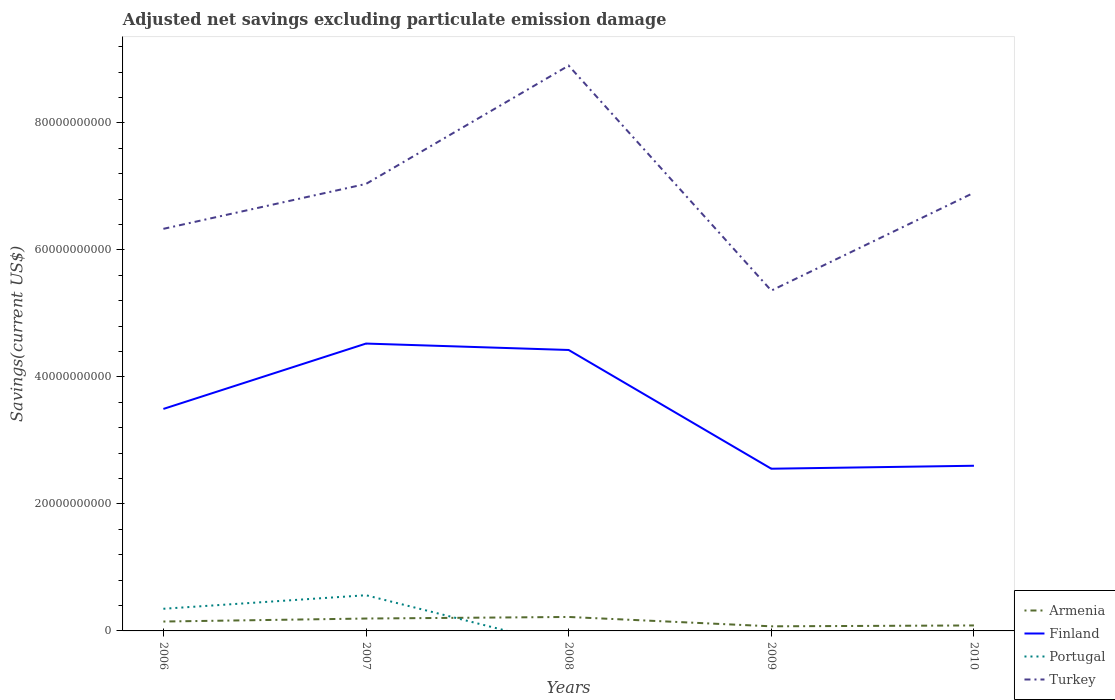Is the number of lines equal to the number of legend labels?
Your answer should be compact. No. Across all years, what is the maximum adjusted net savings in Turkey?
Give a very brief answer. 5.36e+1. What is the total adjusted net savings in Turkey in the graph?
Keep it short and to the point. 3.54e+1. What is the difference between the highest and the second highest adjusted net savings in Portugal?
Ensure brevity in your answer.  5.62e+09. What is the difference between the highest and the lowest adjusted net savings in Portugal?
Your response must be concise. 2. How many lines are there?
Your answer should be very brief. 4. What is the difference between two consecutive major ticks on the Y-axis?
Keep it short and to the point. 2.00e+1. Where does the legend appear in the graph?
Make the answer very short. Bottom right. How many legend labels are there?
Your answer should be very brief. 4. What is the title of the graph?
Provide a short and direct response. Adjusted net savings excluding particulate emission damage. Does "San Marino" appear as one of the legend labels in the graph?
Keep it short and to the point. No. What is the label or title of the Y-axis?
Your answer should be very brief. Savings(current US$). What is the Savings(current US$) in Armenia in 2006?
Ensure brevity in your answer.  1.48e+09. What is the Savings(current US$) in Finland in 2006?
Your answer should be compact. 3.50e+1. What is the Savings(current US$) of Portugal in 2006?
Offer a terse response. 3.49e+09. What is the Savings(current US$) of Turkey in 2006?
Provide a succinct answer. 6.33e+1. What is the Savings(current US$) in Armenia in 2007?
Offer a very short reply. 1.95e+09. What is the Savings(current US$) of Finland in 2007?
Make the answer very short. 4.53e+1. What is the Savings(current US$) in Portugal in 2007?
Offer a terse response. 5.62e+09. What is the Savings(current US$) in Turkey in 2007?
Provide a short and direct response. 7.04e+1. What is the Savings(current US$) in Armenia in 2008?
Give a very brief answer. 2.20e+09. What is the Savings(current US$) of Finland in 2008?
Ensure brevity in your answer.  4.42e+1. What is the Savings(current US$) of Turkey in 2008?
Give a very brief answer. 8.90e+1. What is the Savings(current US$) of Armenia in 2009?
Your answer should be very brief. 7.25e+08. What is the Savings(current US$) of Finland in 2009?
Offer a very short reply. 2.55e+1. What is the Savings(current US$) of Portugal in 2009?
Your answer should be very brief. 0. What is the Savings(current US$) in Turkey in 2009?
Offer a very short reply. 5.36e+1. What is the Savings(current US$) of Armenia in 2010?
Offer a very short reply. 8.62e+08. What is the Savings(current US$) of Finland in 2010?
Your answer should be compact. 2.60e+1. What is the Savings(current US$) in Portugal in 2010?
Your answer should be compact. 0. What is the Savings(current US$) in Turkey in 2010?
Give a very brief answer. 6.90e+1. Across all years, what is the maximum Savings(current US$) in Armenia?
Your response must be concise. 2.20e+09. Across all years, what is the maximum Savings(current US$) in Finland?
Your answer should be compact. 4.53e+1. Across all years, what is the maximum Savings(current US$) of Portugal?
Offer a terse response. 5.62e+09. Across all years, what is the maximum Savings(current US$) in Turkey?
Your answer should be very brief. 8.90e+1. Across all years, what is the minimum Savings(current US$) of Armenia?
Your answer should be compact. 7.25e+08. Across all years, what is the minimum Savings(current US$) in Finland?
Offer a very short reply. 2.55e+1. Across all years, what is the minimum Savings(current US$) of Portugal?
Provide a short and direct response. 0. Across all years, what is the minimum Savings(current US$) in Turkey?
Your answer should be compact. 5.36e+1. What is the total Savings(current US$) in Armenia in the graph?
Make the answer very short. 7.21e+09. What is the total Savings(current US$) of Finland in the graph?
Give a very brief answer. 1.76e+11. What is the total Savings(current US$) of Portugal in the graph?
Your answer should be very brief. 9.11e+09. What is the total Savings(current US$) of Turkey in the graph?
Provide a short and direct response. 3.45e+11. What is the difference between the Savings(current US$) in Armenia in 2006 and that in 2007?
Provide a succinct answer. -4.72e+08. What is the difference between the Savings(current US$) in Finland in 2006 and that in 2007?
Your response must be concise. -1.03e+1. What is the difference between the Savings(current US$) of Portugal in 2006 and that in 2007?
Your response must be concise. -2.13e+09. What is the difference between the Savings(current US$) in Turkey in 2006 and that in 2007?
Offer a very short reply. -7.07e+09. What is the difference between the Savings(current US$) of Armenia in 2006 and that in 2008?
Offer a terse response. -7.20e+08. What is the difference between the Savings(current US$) of Finland in 2006 and that in 2008?
Provide a short and direct response. -9.28e+09. What is the difference between the Savings(current US$) of Turkey in 2006 and that in 2008?
Give a very brief answer. -2.57e+1. What is the difference between the Savings(current US$) in Armenia in 2006 and that in 2009?
Your answer should be very brief. 7.54e+08. What is the difference between the Savings(current US$) in Finland in 2006 and that in 2009?
Your answer should be compact. 9.42e+09. What is the difference between the Savings(current US$) in Turkey in 2006 and that in 2009?
Offer a very short reply. 9.72e+09. What is the difference between the Savings(current US$) of Armenia in 2006 and that in 2010?
Make the answer very short. 6.17e+08. What is the difference between the Savings(current US$) of Finland in 2006 and that in 2010?
Keep it short and to the point. 8.95e+09. What is the difference between the Savings(current US$) in Turkey in 2006 and that in 2010?
Give a very brief answer. -5.69e+09. What is the difference between the Savings(current US$) in Armenia in 2007 and that in 2008?
Your response must be concise. -2.48e+08. What is the difference between the Savings(current US$) in Finland in 2007 and that in 2008?
Offer a terse response. 1.01e+09. What is the difference between the Savings(current US$) in Turkey in 2007 and that in 2008?
Provide a short and direct response. -1.86e+1. What is the difference between the Savings(current US$) of Armenia in 2007 and that in 2009?
Offer a very short reply. 1.23e+09. What is the difference between the Savings(current US$) in Finland in 2007 and that in 2009?
Your answer should be very brief. 1.97e+1. What is the difference between the Savings(current US$) of Turkey in 2007 and that in 2009?
Your answer should be compact. 1.68e+1. What is the difference between the Savings(current US$) in Armenia in 2007 and that in 2010?
Make the answer very short. 1.09e+09. What is the difference between the Savings(current US$) in Finland in 2007 and that in 2010?
Offer a terse response. 1.92e+1. What is the difference between the Savings(current US$) of Turkey in 2007 and that in 2010?
Offer a very short reply. 1.39e+09. What is the difference between the Savings(current US$) in Armenia in 2008 and that in 2009?
Offer a very short reply. 1.47e+09. What is the difference between the Savings(current US$) of Finland in 2008 and that in 2009?
Your response must be concise. 1.87e+1. What is the difference between the Savings(current US$) in Turkey in 2008 and that in 2009?
Your response must be concise. 3.54e+1. What is the difference between the Savings(current US$) of Armenia in 2008 and that in 2010?
Offer a terse response. 1.34e+09. What is the difference between the Savings(current US$) of Finland in 2008 and that in 2010?
Offer a very short reply. 1.82e+1. What is the difference between the Savings(current US$) in Turkey in 2008 and that in 2010?
Offer a very short reply. 2.00e+1. What is the difference between the Savings(current US$) in Armenia in 2009 and that in 2010?
Keep it short and to the point. -1.37e+08. What is the difference between the Savings(current US$) in Finland in 2009 and that in 2010?
Your answer should be compact. -4.69e+08. What is the difference between the Savings(current US$) in Turkey in 2009 and that in 2010?
Ensure brevity in your answer.  -1.54e+1. What is the difference between the Savings(current US$) in Armenia in 2006 and the Savings(current US$) in Finland in 2007?
Your answer should be very brief. -4.38e+1. What is the difference between the Savings(current US$) of Armenia in 2006 and the Savings(current US$) of Portugal in 2007?
Provide a succinct answer. -4.14e+09. What is the difference between the Savings(current US$) of Armenia in 2006 and the Savings(current US$) of Turkey in 2007?
Give a very brief answer. -6.89e+1. What is the difference between the Savings(current US$) of Finland in 2006 and the Savings(current US$) of Portugal in 2007?
Your answer should be very brief. 2.93e+1. What is the difference between the Savings(current US$) in Finland in 2006 and the Savings(current US$) in Turkey in 2007?
Give a very brief answer. -3.54e+1. What is the difference between the Savings(current US$) of Portugal in 2006 and the Savings(current US$) of Turkey in 2007?
Offer a very short reply. -6.69e+1. What is the difference between the Savings(current US$) in Armenia in 2006 and the Savings(current US$) in Finland in 2008?
Offer a terse response. -4.28e+1. What is the difference between the Savings(current US$) of Armenia in 2006 and the Savings(current US$) of Turkey in 2008?
Make the answer very short. -8.75e+1. What is the difference between the Savings(current US$) of Finland in 2006 and the Savings(current US$) of Turkey in 2008?
Keep it short and to the point. -5.41e+1. What is the difference between the Savings(current US$) of Portugal in 2006 and the Savings(current US$) of Turkey in 2008?
Give a very brief answer. -8.55e+1. What is the difference between the Savings(current US$) of Armenia in 2006 and the Savings(current US$) of Finland in 2009?
Your answer should be compact. -2.41e+1. What is the difference between the Savings(current US$) of Armenia in 2006 and the Savings(current US$) of Turkey in 2009?
Ensure brevity in your answer.  -5.21e+1. What is the difference between the Savings(current US$) in Finland in 2006 and the Savings(current US$) in Turkey in 2009?
Your answer should be compact. -1.86e+1. What is the difference between the Savings(current US$) of Portugal in 2006 and the Savings(current US$) of Turkey in 2009?
Keep it short and to the point. -5.01e+1. What is the difference between the Savings(current US$) of Armenia in 2006 and the Savings(current US$) of Finland in 2010?
Keep it short and to the point. -2.45e+1. What is the difference between the Savings(current US$) of Armenia in 2006 and the Savings(current US$) of Turkey in 2010?
Offer a terse response. -6.75e+1. What is the difference between the Savings(current US$) of Finland in 2006 and the Savings(current US$) of Turkey in 2010?
Provide a succinct answer. -3.40e+1. What is the difference between the Savings(current US$) of Portugal in 2006 and the Savings(current US$) of Turkey in 2010?
Your response must be concise. -6.55e+1. What is the difference between the Savings(current US$) of Armenia in 2007 and the Savings(current US$) of Finland in 2008?
Provide a succinct answer. -4.23e+1. What is the difference between the Savings(current US$) in Armenia in 2007 and the Savings(current US$) in Turkey in 2008?
Your answer should be very brief. -8.71e+1. What is the difference between the Savings(current US$) in Finland in 2007 and the Savings(current US$) in Turkey in 2008?
Offer a terse response. -4.38e+1. What is the difference between the Savings(current US$) in Portugal in 2007 and the Savings(current US$) in Turkey in 2008?
Your answer should be compact. -8.34e+1. What is the difference between the Savings(current US$) in Armenia in 2007 and the Savings(current US$) in Finland in 2009?
Your answer should be very brief. -2.36e+1. What is the difference between the Savings(current US$) in Armenia in 2007 and the Savings(current US$) in Turkey in 2009?
Your answer should be very brief. -5.16e+1. What is the difference between the Savings(current US$) of Finland in 2007 and the Savings(current US$) of Turkey in 2009?
Offer a terse response. -8.34e+09. What is the difference between the Savings(current US$) in Portugal in 2007 and the Savings(current US$) in Turkey in 2009?
Your answer should be very brief. -4.80e+1. What is the difference between the Savings(current US$) in Armenia in 2007 and the Savings(current US$) in Finland in 2010?
Provide a short and direct response. -2.41e+1. What is the difference between the Savings(current US$) in Armenia in 2007 and the Savings(current US$) in Turkey in 2010?
Provide a short and direct response. -6.71e+1. What is the difference between the Savings(current US$) of Finland in 2007 and the Savings(current US$) of Turkey in 2010?
Provide a short and direct response. -2.38e+1. What is the difference between the Savings(current US$) in Portugal in 2007 and the Savings(current US$) in Turkey in 2010?
Ensure brevity in your answer.  -6.34e+1. What is the difference between the Savings(current US$) of Armenia in 2008 and the Savings(current US$) of Finland in 2009?
Your response must be concise. -2.33e+1. What is the difference between the Savings(current US$) of Armenia in 2008 and the Savings(current US$) of Turkey in 2009?
Provide a short and direct response. -5.14e+1. What is the difference between the Savings(current US$) in Finland in 2008 and the Savings(current US$) in Turkey in 2009?
Give a very brief answer. -9.35e+09. What is the difference between the Savings(current US$) of Armenia in 2008 and the Savings(current US$) of Finland in 2010?
Provide a short and direct response. -2.38e+1. What is the difference between the Savings(current US$) of Armenia in 2008 and the Savings(current US$) of Turkey in 2010?
Your response must be concise. -6.68e+1. What is the difference between the Savings(current US$) in Finland in 2008 and the Savings(current US$) in Turkey in 2010?
Your answer should be very brief. -2.48e+1. What is the difference between the Savings(current US$) in Armenia in 2009 and the Savings(current US$) in Finland in 2010?
Your response must be concise. -2.53e+1. What is the difference between the Savings(current US$) in Armenia in 2009 and the Savings(current US$) in Turkey in 2010?
Your answer should be compact. -6.83e+1. What is the difference between the Savings(current US$) in Finland in 2009 and the Savings(current US$) in Turkey in 2010?
Give a very brief answer. -4.35e+1. What is the average Savings(current US$) in Armenia per year?
Ensure brevity in your answer.  1.44e+09. What is the average Savings(current US$) in Finland per year?
Your answer should be compact. 3.52e+1. What is the average Savings(current US$) of Portugal per year?
Offer a terse response. 1.82e+09. What is the average Savings(current US$) in Turkey per year?
Keep it short and to the point. 6.91e+1. In the year 2006, what is the difference between the Savings(current US$) in Armenia and Savings(current US$) in Finland?
Offer a terse response. -3.35e+1. In the year 2006, what is the difference between the Savings(current US$) of Armenia and Savings(current US$) of Portugal?
Offer a terse response. -2.01e+09. In the year 2006, what is the difference between the Savings(current US$) in Armenia and Savings(current US$) in Turkey?
Offer a terse response. -6.18e+1. In the year 2006, what is the difference between the Savings(current US$) of Finland and Savings(current US$) of Portugal?
Offer a terse response. 3.15e+1. In the year 2006, what is the difference between the Savings(current US$) in Finland and Savings(current US$) in Turkey?
Make the answer very short. -2.84e+1. In the year 2006, what is the difference between the Savings(current US$) in Portugal and Savings(current US$) in Turkey?
Your answer should be very brief. -5.98e+1. In the year 2007, what is the difference between the Savings(current US$) in Armenia and Savings(current US$) in Finland?
Provide a short and direct response. -4.33e+1. In the year 2007, what is the difference between the Savings(current US$) in Armenia and Savings(current US$) in Portugal?
Ensure brevity in your answer.  -3.67e+09. In the year 2007, what is the difference between the Savings(current US$) in Armenia and Savings(current US$) in Turkey?
Offer a terse response. -6.84e+1. In the year 2007, what is the difference between the Savings(current US$) of Finland and Savings(current US$) of Portugal?
Your answer should be compact. 3.96e+1. In the year 2007, what is the difference between the Savings(current US$) in Finland and Savings(current US$) in Turkey?
Make the answer very short. -2.51e+1. In the year 2007, what is the difference between the Savings(current US$) in Portugal and Savings(current US$) in Turkey?
Keep it short and to the point. -6.48e+1. In the year 2008, what is the difference between the Savings(current US$) in Armenia and Savings(current US$) in Finland?
Offer a very short reply. -4.20e+1. In the year 2008, what is the difference between the Savings(current US$) in Armenia and Savings(current US$) in Turkey?
Provide a succinct answer. -8.68e+1. In the year 2008, what is the difference between the Savings(current US$) of Finland and Savings(current US$) of Turkey?
Make the answer very short. -4.48e+1. In the year 2009, what is the difference between the Savings(current US$) in Armenia and Savings(current US$) in Finland?
Provide a succinct answer. -2.48e+1. In the year 2009, what is the difference between the Savings(current US$) of Armenia and Savings(current US$) of Turkey?
Provide a succinct answer. -5.29e+1. In the year 2009, what is the difference between the Savings(current US$) of Finland and Savings(current US$) of Turkey?
Offer a terse response. -2.81e+1. In the year 2010, what is the difference between the Savings(current US$) of Armenia and Savings(current US$) of Finland?
Give a very brief answer. -2.51e+1. In the year 2010, what is the difference between the Savings(current US$) of Armenia and Savings(current US$) of Turkey?
Provide a short and direct response. -6.81e+1. In the year 2010, what is the difference between the Savings(current US$) in Finland and Savings(current US$) in Turkey?
Your answer should be compact. -4.30e+1. What is the ratio of the Savings(current US$) in Armenia in 2006 to that in 2007?
Your response must be concise. 0.76. What is the ratio of the Savings(current US$) in Finland in 2006 to that in 2007?
Ensure brevity in your answer.  0.77. What is the ratio of the Savings(current US$) of Portugal in 2006 to that in 2007?
Provide a short and direct response. 0.62. What is the ratio of the Savings(current US$) of Turkey in 2006 to that in 2007?
Offer a terse response. 0.9. What is the ratio of the Savings(current US$) in Armenia in 2006 to that in 2008?
Ensure brevity in your answer.  0.67. What is the ratio of the Savings(current US$) in Finland in 2006 to that in 2008?
Provide a short and direct response. 0.79. What is the ratio of the Savings(current US$) of Turkey in 2006 to that in 2008?
Keep it short and to the point. 0.71. What is the ratio of the Savings(current US$) in Armenia in 2006 to that in 2009?
Give a very brief answer. 2.04. What is the ratio of the Savings(current US$) in Finland in 2006 to that in 2009?
Provide a short and direct response. 1.37. What is the ratio of the Savings(current US$) in Turkey in 2006 to that in 2009?
Provide a short and direct response. 1.18. What is the ratio of the Savings(current US$) in Armenia in 2006 to that in 2010?
Provide a short and direct response. 1.72. What is the ratio of the Savings(current US$) in Finland in 2006 to that in 2010?
Provide a succinct answer. 1.34. What is the ratio of the Savings(current US$) in Turkey in 2006 to that in 2010?
Your response must be concise. 0.92. What is the ratio of the Savings(current US$) in Armenia in 2007 to that in 2008?
Your response must be concise. 0.89. What is the ratio of the Savings(current US$) of Finland in 2007 to that in 2008?
Your answer should be very brief. 1.02. What is the ratio of the Savings(current US$) of Turkey in 2007 to that in 2008?
Your answer should be very brief. 0.79. What is the ratio of the Savings(current US$) of Armenia in 2007 to that in 2009?
Your response must be concise. 2.69. What is the ratio of the Savings(current US$) in Finland in 2007 to that in 2009?
Ensure brevity in your answer.  1.77. What is the ratio of the Savings(current US$) of Turkey in 2007 to that in 2009?
Ensure brevity in your answer.  1.31. What is the ratio of the Savings(current US$) in Armenia in 2007 to that in 2010?
Make the answer very short. 2.26. What is the ratio of the Savings(current US$) of Finland in 2007 to that in 2010?
Your answer should be compact. 1.74. What is the ratio of the Savings(current US$) in Turkey in 2007 to that in 2010?
Keep it short and to the point. 1.02. What is the ratio of the Savings(current US$) in Armenia in 2008 to that in 2009?
Offer a very short reply. 3.03. What is the ratio of the Savings(current US$) of Finland in 2008 to that in 2009?
Keep it short and to the point. 1.73. What is the ratio of the Savings(current US$) in Turkey in 2008 to that in 2009?
Make the answer very short. 1.66. What is the ratio of the Savings(current US$) in Armenia in 2008 to that in 2010?
Provide a short and direct response. 2.55. What is the ratio of the Savings(current US$) of Finland in 2008 to that in 2010?
Keep it short and to the point. 1.7. What is the ratio of the Savings(current US$) of Turkey in 2008 to that in 2010?
Provide a succinct answer. 1.29. What is the ratio of the Savings(current US$) of Armenia in 2009 to that in 2010?
Give a very brief answer. 0.84. What is the ratio of the Savings(current US$) of Turkey in 2009 to that in 2010?
Ensure brevity in your answer.  0.78. What is the difference between the highest and the second highest Savings(current US$) of Armenia?
Your answer should be compact. 2.48e+08. What is the difference between the highest and the second highest Savings(current US$) of Finland?
Your response must be concise. 1.01e+09. What is the difference between the highest and the second highest Savings(current US$) of Turkey?
Provide a short and direct response. 1.86e+1. What is the difference between the highest and the lowest Savings(current US$) in Armenia?
Provide a short and direct response. 1.47e+09. What is the difference between the highest and the lowest Savings(current US$) in Finland?
Ensure brevity in your answer.  1.97e+1. What is the difference between the highest and the lowest Savings(current US$) in Portugal?
Offer a terse response. 5.62e+09. What is the difference between the highest and the lowest Savings(current US$) of Turkey?
Your answer should be compact. 3.54e+1. 